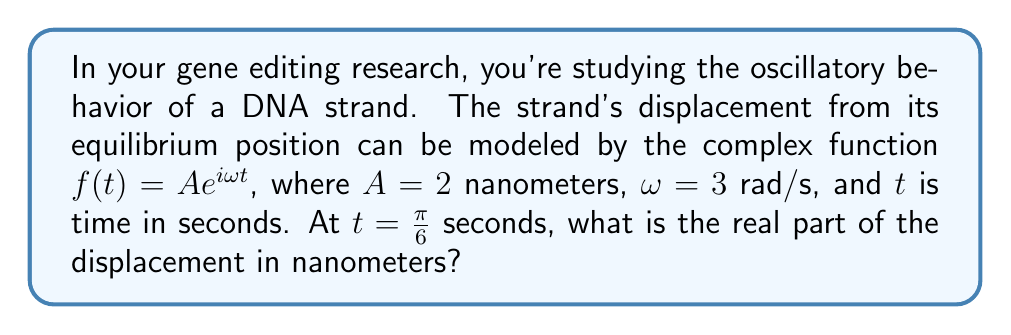Help me with this question. Let's approach this step-by-step:

1) We're given the complex function $f(t) = Ae^{i\omega t}$, where:
   $A = 2$ nm
   $\omega = 3$ rad/s
   $t = \frac{\pi}{6}$ s

2) Substituting these values into the function:
   $f(\frac{\pi}{6}) = 2e^{i3\frac{\pi}{6}}$

3) Simplify the exponent:
   $f(\frac{\pi}{6}) = 2e^{i\frac{\pi}{2}}$

4) Recall Euler's formula: $e^{ix} = \cos x + i \sin x$

5) Apply Euler's formula:
   $f(\frac{\pi}{6}) = 2(\cos \frac{\pi}{2} + i \sin \frac{\pi}{2})$

6) Evaluate $\cos \frac{\pi}{2}$ and $\sin \frac{\pi}{2}$:
   $f(\frac{\pi}{6}) = 2(0 + i)$

7) Simplify:
   $f(\frac{\pi}{6}) = 2i$

8) The question asks for the real part of the displacement. The real part of $2i$ is 0.

Therefore, the real part of the displacement at $t = \frac{\pi}{6}$ seconds is 0 nanometers.
Answer: 0 nm 